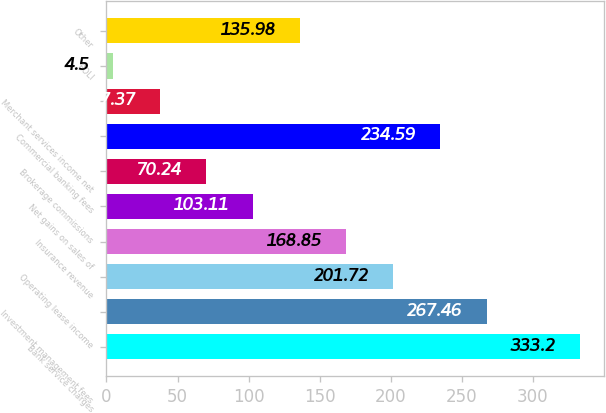Convert chart. <chart><loc_0><loc_0><loc_500><loc_500><bar_chart><fcel>Bank service charges<fcel>Investment management fees<fcel>Operating lease income<fcel>Insurance revenue<fcel>Net gains on sales of<fcel>Brokerage commissions<fcel>Commercial banking fees<fcel>Merchant services income net<fcel>BOLI<fcel>Other<nl><fcel>333.2<fcel>267.46<fcel>201.72<fcel>168.85<fcel>103.11<fcel>70.24<fcel>234.59<fcel>37.37<fcel>4.5<fcel>135.98<nl></chart> 